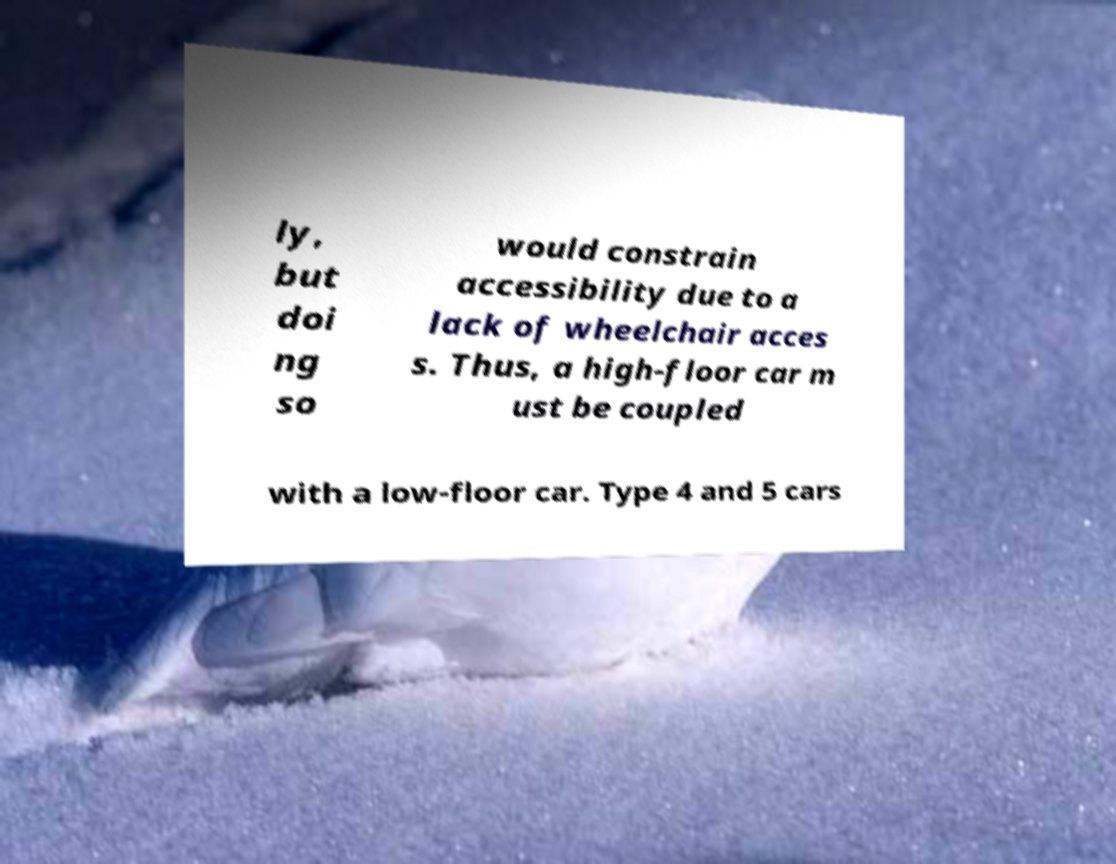What messages or text are displayed in this image? I need them in a readable, typed format. ly, but doi ng so would constrain accessibility due to a lack of wheelchair acces s. Thus, a high-floor car m ust be coupled with a low-floor car. Type 4 and 5 cars 